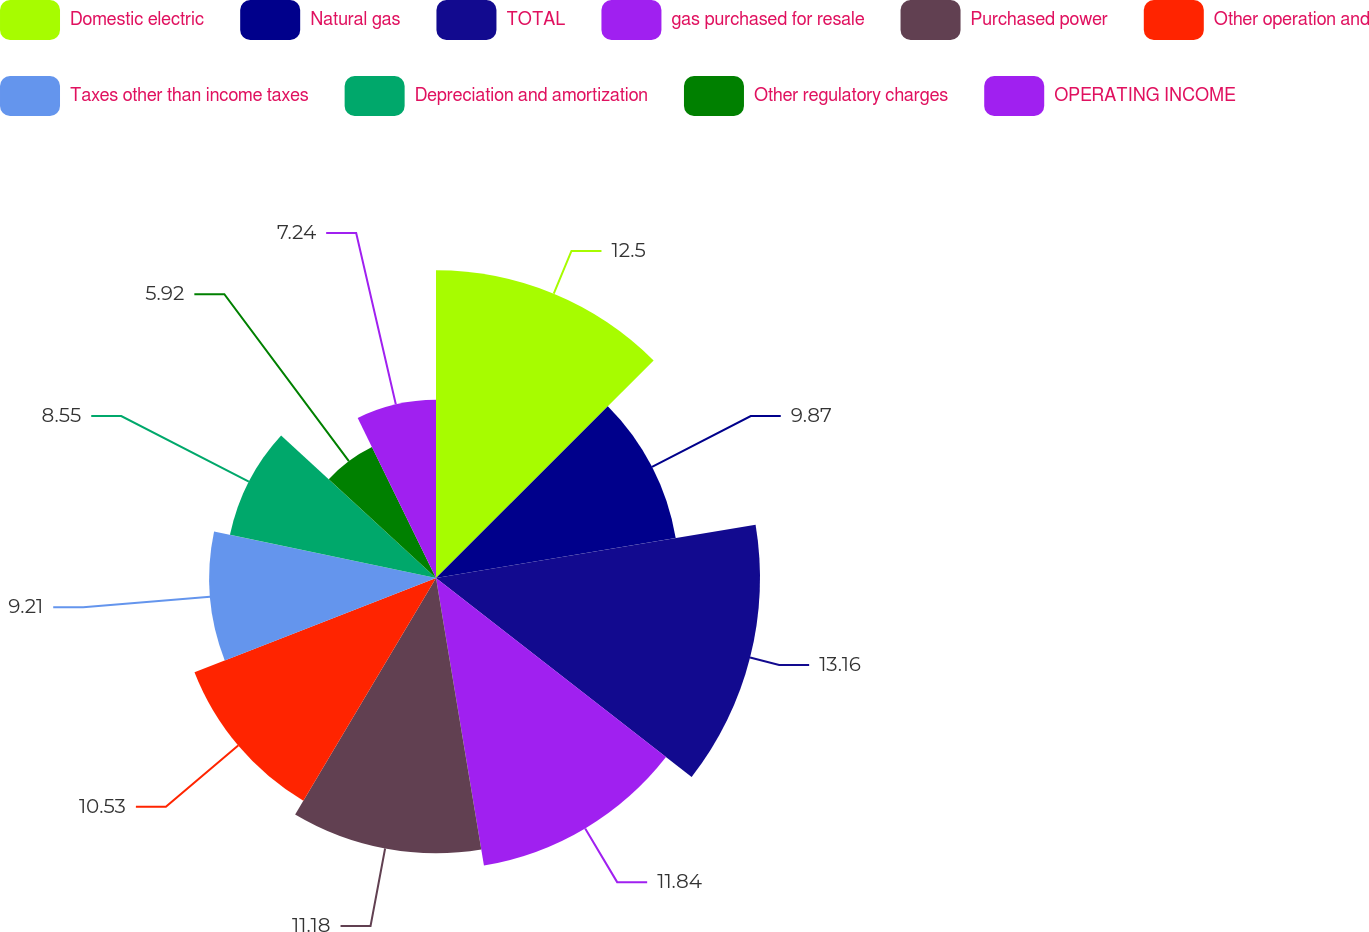Convert chart to OTSL. <chart><loc_0><loc_0><loc_500><loc_500><pie_chart><fcel>Domestic electric<fcel>Natural gas<fcel>TOTAL<fcel>gas purchased for resale<fcel>Purchased power<fcel>Other operation and<fcel>Taxes other than income taxes<fcel>Depreciation and amortization<fcel>Other regulatory charges<fcel>OPERATING INCOME<nl><fcel>12.5%<fcel>9.87%<fcel>13.16%<fcel>11.84%<fcel>11.18%<fcel>10.53%<fcel>9.21%<fcel>8.55%<fcel>5.92%<fcel>7.24%<nl></chart> 